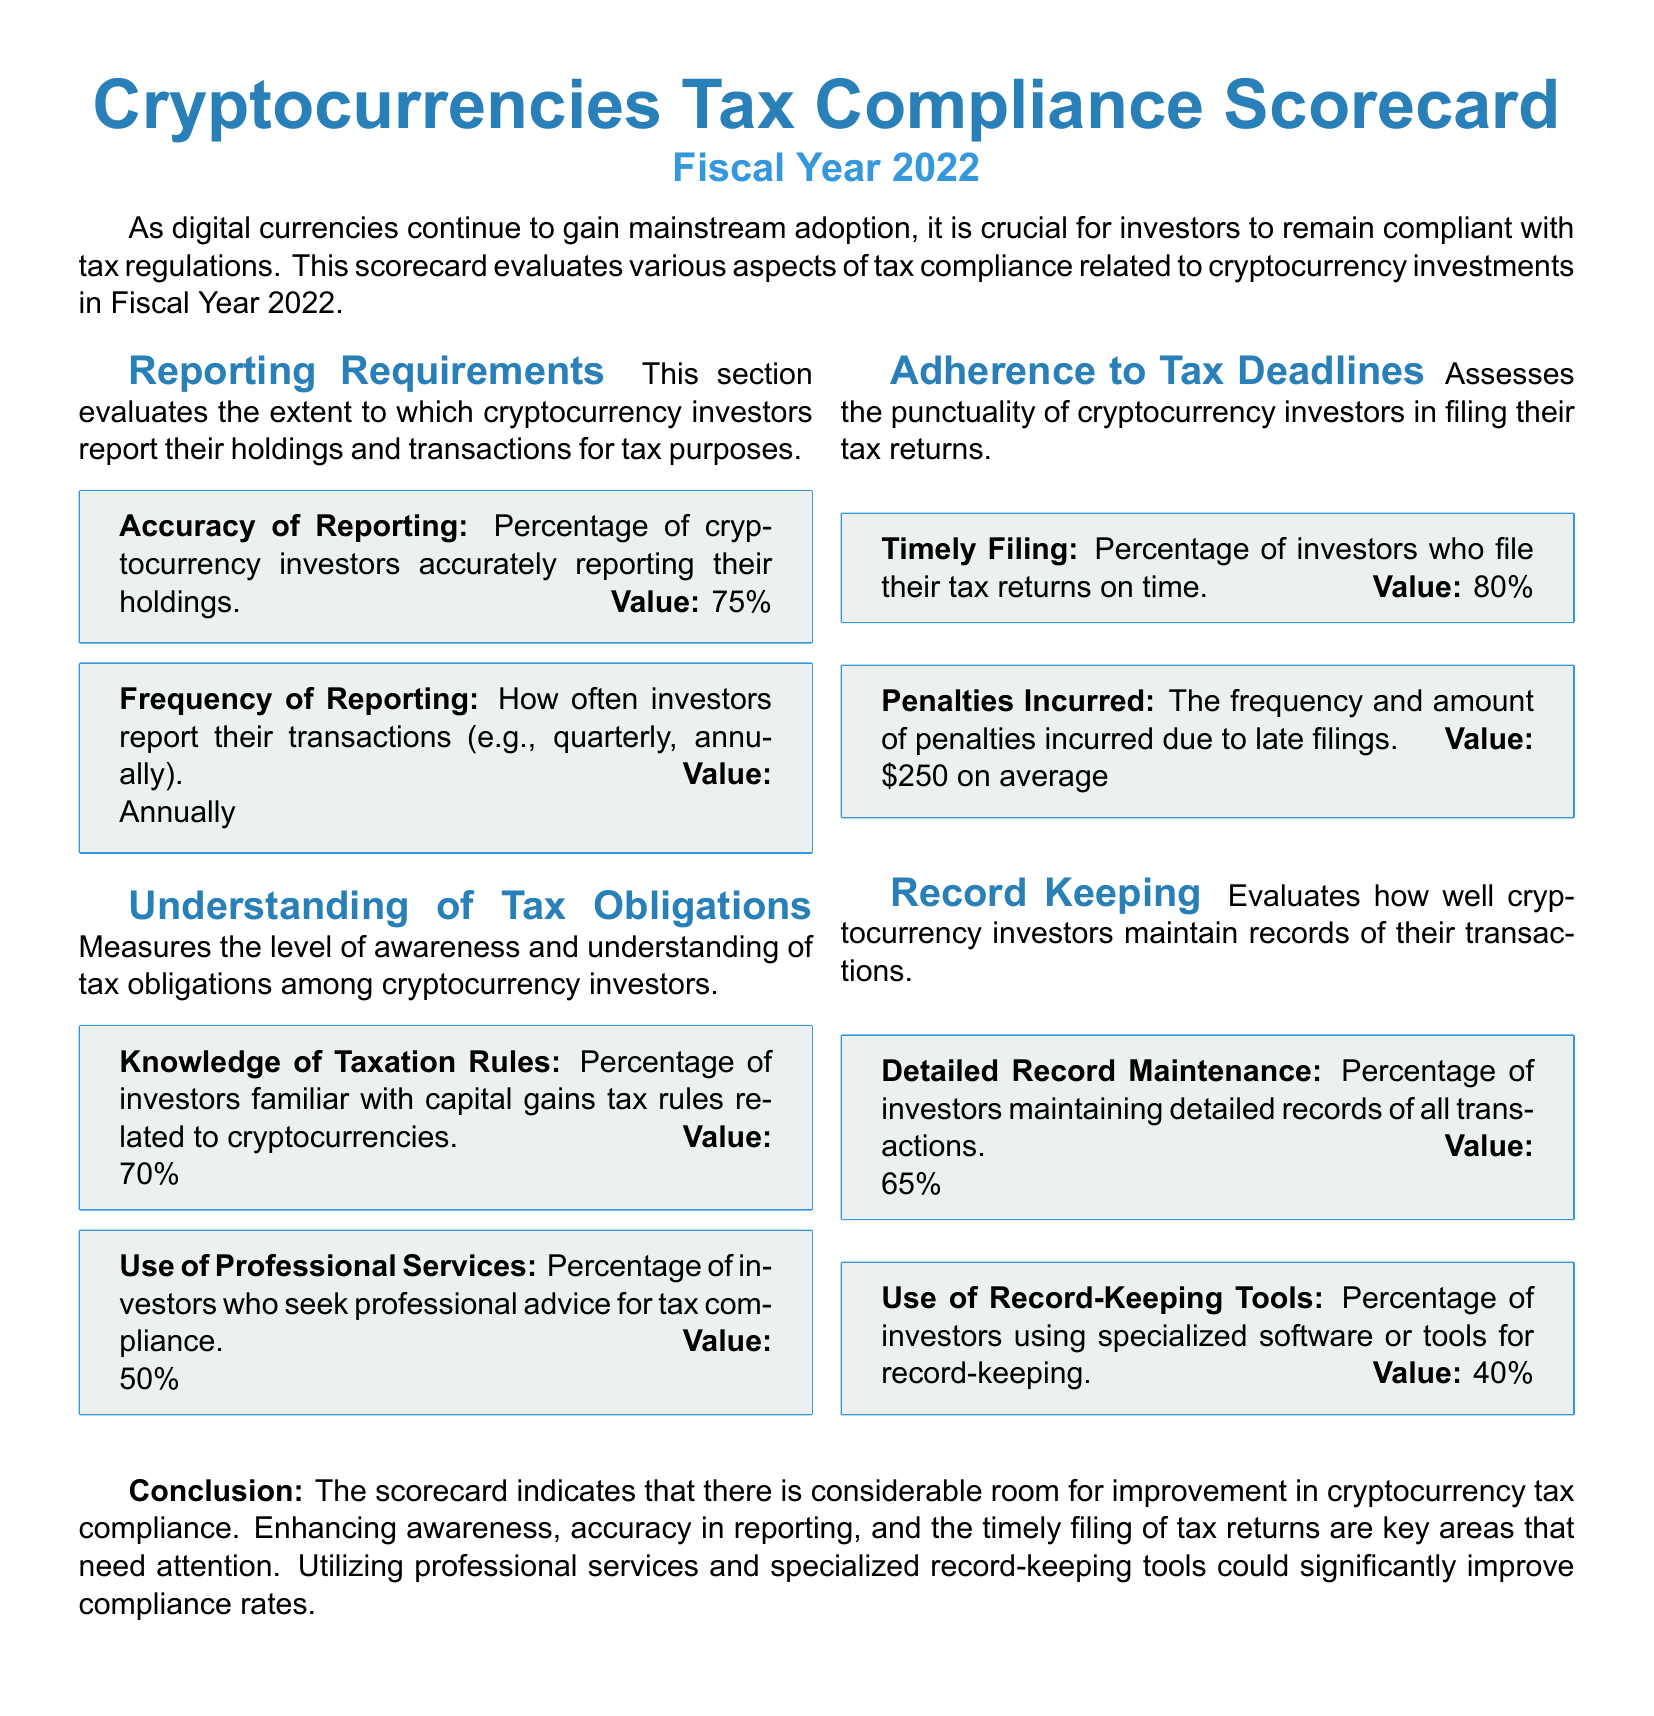What is the percentage of investors accurately reporting their holdings? The document states that 75% of cryptocurrency investors accurately report their holdings.
Answer: 75% How often do investors report their transactions? The document indicates that investors report their transactions annually.
Answer: Annually What percentage of investors are familiar with capital gains tax rules? According to the scorecard, 70% of investors are familiar with capital gains tax rules related to cryptocurrencies.
Answer: 70% What is the average penalty incurred due to late filings? The document mentions that the average penalty incurred due to late filings is $250.
Answer: $250 What percentage of investors maintain detailed records of all transactions? The scorecard shows that 65% of investors maintain detailed records of all transactions.
Answer: 65% What are the key areas that need attention for better compliance? The conclusion emphasizes the need for improvement in awareness, accuracy in reporting, and timely filing of tax returns.
Answer: Awareness, accuracy in reporting, timely filing What percentage of investors use specialized software or tools for record-keeping? The document states that 40% of investors use specialized software or tools for record-keeping.
Answer: 40% Which area evaluates the punctuality of cryptocurrency investors in filing tax returns? The document refers to the "Adherence to Tax Deadlines" section regarding the punctuality of filing tax returns.
Answer: Adherence to Tax Deadlines What is the document's overall assessment of cryptocurrency tax compliance? The conclusion indicates that there is considerable room for improvement in cryptocurrency tax compliance.
Answer: Considerable room for improvement 